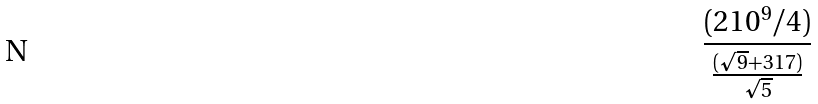Convert formula to latex. <formula><loc_0><loc_0><loc_500><loc_500>\frac { ( 2 1 0 ^ { 9 } / 4 ) } { \frac { ( \sqrt { 9 } + 3 1 7 ) } { \sqrt { 5 } } }</formula> 